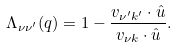<formula> <loc_0><loc_0><loc_500><loc_500>\Lambda _ { \nu \nu ^ { \prime } } ( { q } ) = 1 - \frac { { v } _ { \nu ^ { \prime } { k } ^ { \prime } } \cdot { \hat { u } } } { { v } _ { \nu { k } } \cdot \hat { u } } .</formula> 